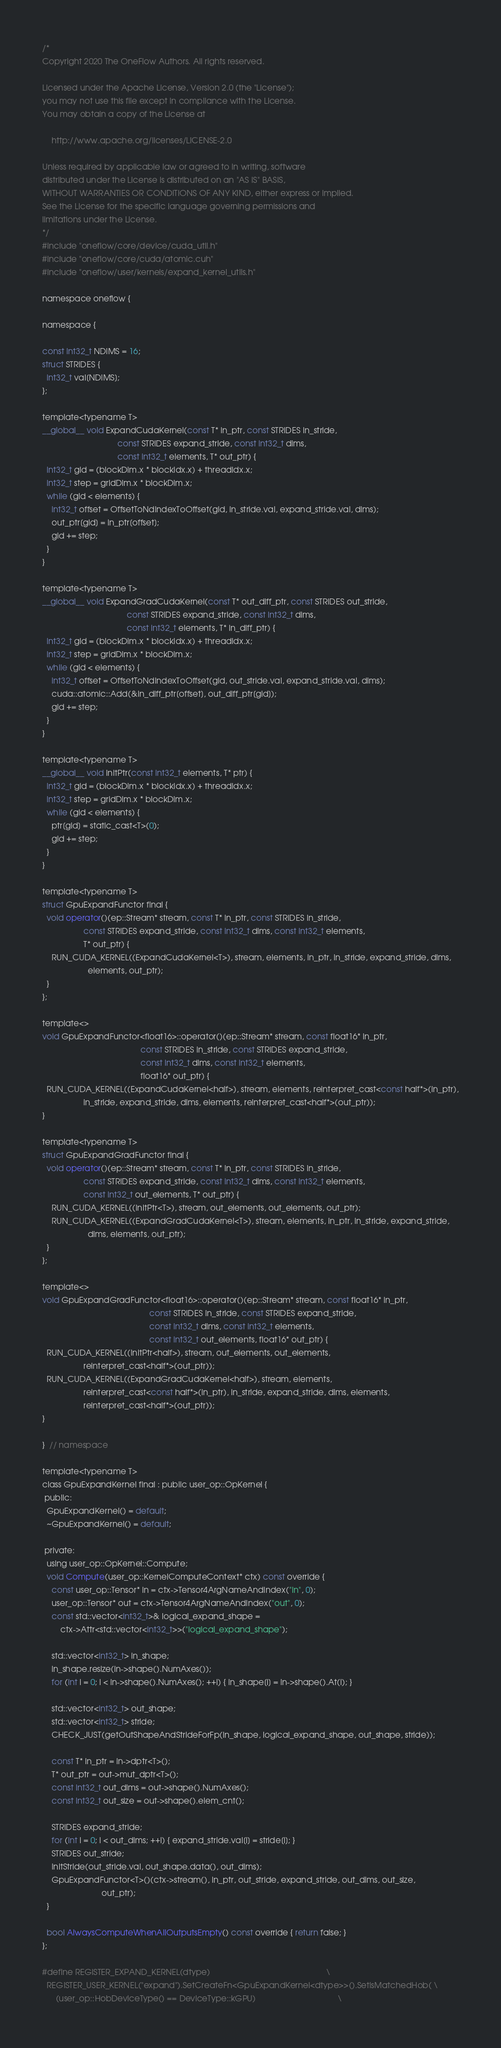Convert code to text. <code><loc_0><loc_0><loc_500><loc_500><_Cuda_>/*
Copyright 2020 The OneFlow Authors. All rights reserved.

Licensed under the Apache License, Version 2.0 (the "License");
you may not use this file except in compliance with the License.
You may obtain a copy of the License at

    http://www.apache.org/licenses/LICENSE-2.0

Unless required by applicable law or agreed to in writing, software
distributed under the License is distributed on an "AS IS" BASIS,
WITHOUT WARRANTIES OR CONDITIONS OF ANY KIND, either express or implied.
See the License for the specific language governing permissions and
limitations under the License.
*/
#include "oneflow/core/device/cuda_util.h"
#include "oneflow/core/cuda/atomic.cuh"
#include "oneflow/user/kernels/expand_kernel_utils.h"

namespace oneflow {

namespace {

const int32_t NDIMS = 16;
struct STRIDES {
  int32_t val[NDIMS];
};

template<typename T>
__global__ void ExpandCudaKernel(const T* in_ptr, const STRIDES in_stride,
                                 const STRIDES expand_stride, const int32_t dims,
                                 const int32_t elements, T* out_ptr) {
  int32_t gid = (blockDim.x * blockIdx.x) + threadIdx.x;
  int32_t step = gridDim.x * blockDim.x;
  while (gid < elements) {
    int32_t offset = OffsetToNdIndexToOffset(gid, in_stride.val, expand_stride.val, dims);
    out_ptr[gid] = in_ptr[offset];
    gid += step;
  }
}

template<typename T>
__global__ void ExpandGradCudaKernel(const T* out_diff_ptr, const STRIDES out_stride,
                                     const STRIDES expand_stride, const int32_t dims,
                                     const int32_t elements, T* in_diff_ptr) {
  int32_t gid = (blockDim.x * blockIdx.x) + threadIdx.x;
  int32_t step = gridDim.x * blockDim.x;
  while (gid < elements) {
    int32_t offset = OffsetToNdIndexToOffset(gid, out_stride.val, expand_stride.val, dims);
    cuda::atomic::Add(&in_diff_ptr[offset], out_diff_ptr[gid]);
    gid += step;
  }
}

template<typename T>
__global__ void InitPtr(const int32_t elements, T* ptr) {
  int32_t gid = (blockDim.x * blockIdx.x) + threadIdx.x;
  int32_t step = gridDim.x * blockDim.x;
  while (gid < elements) {
    ptr[gid] = static_cast<T>(0);
    gid += step;
  }
}

template<typename T>
struct GpuExpandFunctor final {
  void operator()(ep::Stream* stream, const T* in_ptr, const STRIDES in_stride,
                  const STRIDES expand_stride, const int32_t dims, const int32_t elements,
                  T* out_ptr) {
    RUN_CUDA_KERNEL((ExpandCudaKernel<T>), stream, elements, in_ptr, in_stride, expand_stride, dims,
                    elements, out_ptr);
  }
};

template<>
void GpuExpandFunctor<float16>::operator()(ep::Stream* stream, const float16* in_ptr,
                                           const STRIDES in_stride, const STRIDES expand_stride,
                                           const int32_t dims, const int32_t elements,
                                           float16* out_ptr) {
  RUN_CUDA_KERNEL((ExpandCudaKernel<half>), stream, elements, reinterpret_cast<const half*>(in_ptr),
                  in_stride, expand_stride, dims, elements, reinterpret_cast<half*>(out_ptr));
}

template<typename T>
struct GpuExpandGradFunctor final {
  void operator()(ep::Stream* stream, const T* in_ptr, const STRIDES in_stride,
                  const STRIDES expand_stride, const int32_t dims, const int32_t elements,
                  const int32_t out_elements, T* out_ptr) {
    RUN_CUDA_KERNEL((InitPtr<T>), stream, out_elements, out_elements, out_ptr);
    RUN_CUDA_KERNEL((ExpandGradCudaKernel<T>), stream, elements, in_ptr, in_stride, expand_stride,
                    dims, elements, out_ptr);
  }
};

template<>
void GpuExpandGradFunctor<float16>::operator()(ep::Stream* stream, const float16* in_ptr,
                                               const STRIDES in_stride, const STRIDES expand_stride,
                                               const int32_t dims, const int32_t elements,
                                               const int32_t out_elements, float16* out_ptr) {
  RUN_CUDA_KERNEL((InitPtr<half>), stream, out_elements, out_elements,
                  reinterpret_cast<half*>(out_ptr));
  RUN_CUDA_KERNEL((ExpandGradCudaKernel<half>), stream, elements,
                  reinterpret_cast<const half*>(in_ptr), in_stride, expand_stride, dims, elements,
                  reinterpret_cast<half*>(out_ptr));
}

}  // namespace

template<typename T>
class GpuExpandKernel final : public user_op::OpKernel {
 public:
  GpuExpandKernel() = default;
  ~GpuExpandKernel() = default;

 private:
  using user_op::OpKernel::Compute;
  void Compute(user_op::KernelComputeContext* ctx) const override {
    const user_op::Tensor* in = ctx->Tensor4ArgNameAndIndex("in", 0);
    user_op::Tensor* out = ctx->Tensor4ArgNameAndIndex("out", 0);
    const std::vector<int32_t>& logical_expand_shape =
        ctx->Attr<std::vector<int32_t>>("logical_expand_shape");

    std::vector<int32_t> in_shape;
    in_shape.resize(in->shape().NumAxes());
    for (int i = 0; i < in->shape().NumAxes(); ++i) { in_shape[i] = in->shape().At(i); }

    std::vector<int32_t> out_shape;
    std::vector<int32_t> stride;
    CHECK_JUST(getOutShapeAndStrideForFp(in_shape, logical_expand_shape, out_shape, stride));

    const T* in_ptr = in->dptr<T>();
    T* out_ptr = out->mut_dptr<T>();
    const int32_t out_dims = out->shape().NumAxes();
    const int32_t out_size = out->shape().elem_cnt();

    STRIDES expand_stride;
    for (int i = 0; i < out_dims; ++i) { expand_stride.val[i] = stride[i]; }
    STRIDES out_stride;
    InitStride(out_stride.val, out_shape.data(), out_dims);
    GpuExpandFunctor<T>()(ctx->stream(), in_ptr, out_stride, expand_stride, out_dims, out_size,
                          out_ptr);
  }

  bool AlwaysComputeWhenAllOutputsEmpty() const override { return false; }
};

#define REGISTER_EXPAND_KERNEL(dtype)                                                   \
  REGISTER_USER_KERNEL("expand").SetCreateFn<GpuExpandKernel<dtype>>().SetIsMatchedHob( \
      (user_op::HobDeviceType() == DeviceType::kGPU)                                    \</code> 